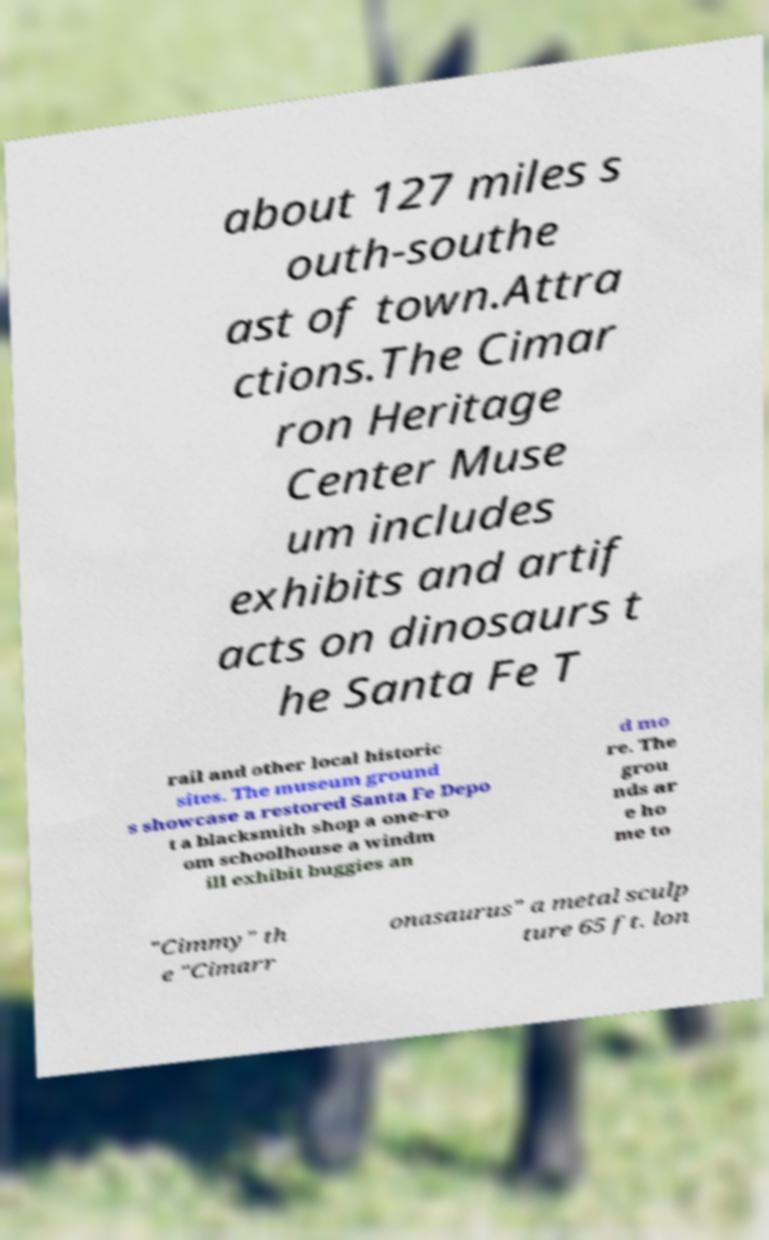Please identify and transcribe the text found in this image. about 127 miles s outh-southe ast of town.Attra ctions.The Cimar ron Heritage Center Muse um includes exhibits and artif acts on dinosaurs t he Santa Fe T rail and other local historic sites. The museum ground s showcase a restored Santa Fe Depo t a blacksmith shop a one-ro om schoolhouse a windm ill exhibit buggies an d mo re. The grou nds ar e ho me to "Cimmy" th e "Cimarr onasaurus" a metal sculp ture 65 ft. lon 